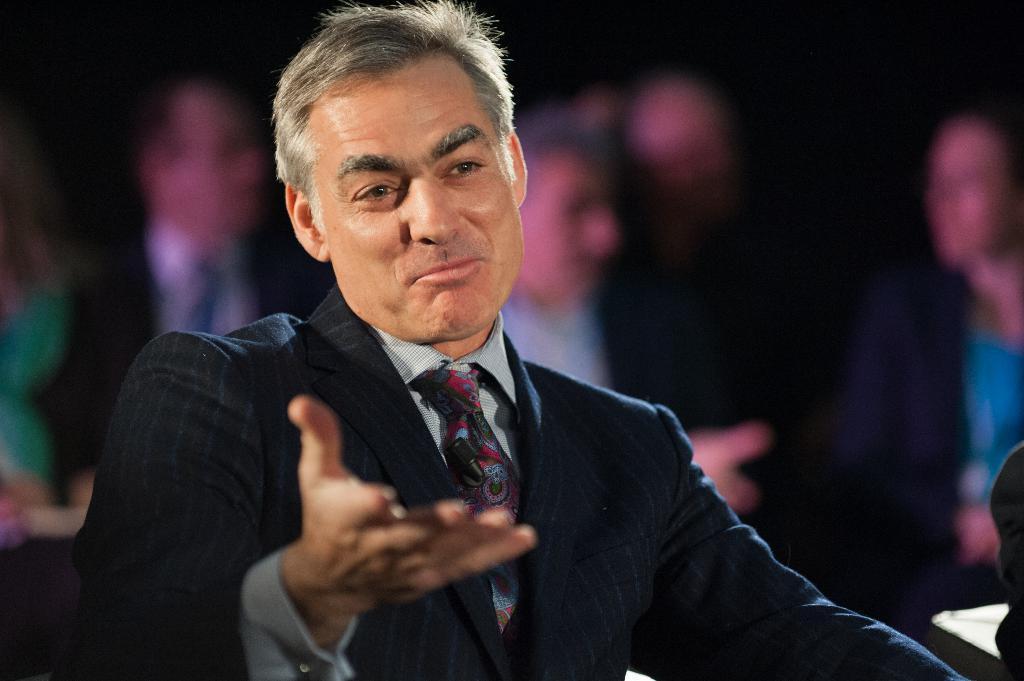Could you give a brief overview of what you see in this image? In the image we can see there is a man sitting and he is wearing formal suit. Behind there are other people sitting and background of the image is blurred. 